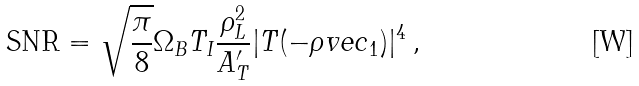Convert formula to latex. <formula><loc_0><loc_0><loc_500><loc_500>\text {SNR} = \sqrt { \frac { \pi } { 8 } } \Omega _ { B } T _ { I } \frac { \rho _ { L } ^ { 2 } } { A ^ { \prime } _ { T } } | T ( - \rho v e c _ { 1 } ) | ^ { 4 } \, ,</formula> 